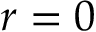Convert formula to latex. <formula><loc_0><loc_0><loc_500><loc_500>r = 0</formula> 